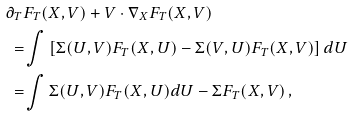<formula> <loc_0><loc_0><loc_500><loc_500>\partial _ { T } & F _ { T } ( X , V ) + V \cdot \nabla _ { X } F _ { T } ( X , V ) \\ = & \int \left [ \Sigma ( U , V ) F _ { T } ( X , U ) - \Sigma ( V , U ) F _ { T } ( X , V ) \right ] d U \\ = & \int \Sigma ( U , V ) F _ { T } ( X , U ) d U - \Sigma F _ { T } ( X , V ) \, ,</formula> 